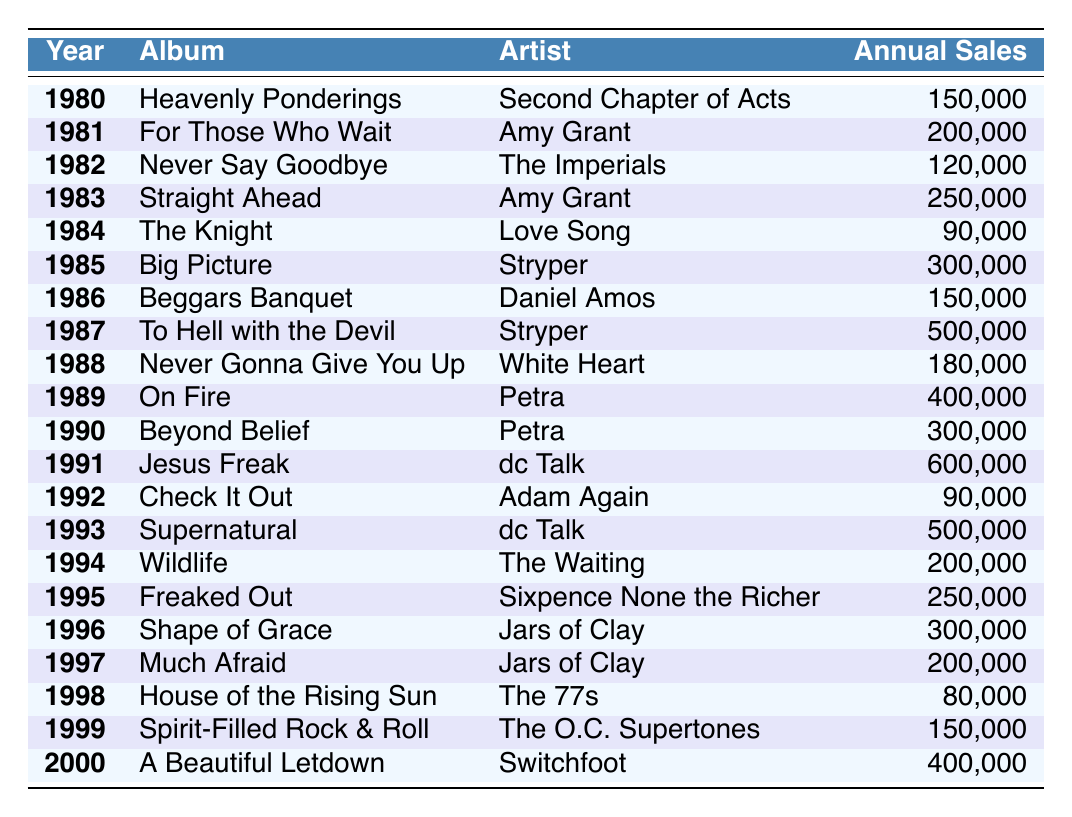What is the total annual sales of albums in 1991? The table shows that the annual sales for the album "Jesus Freak" by dc Talk is 600,000 in 1991. There are no other albums listed for that year.
Answer: 600,000 Which album had the highest annual sales in the table? The album "Jesus Freak" by dc Talk, released in 1991, had the highest annual sales at 600,000, greater than any other album listed in the table.
Answer: Jesus Freak How many albums had annual sales greater than 300,000? The albums with annual sales greater than 300,000 are "To Hell with the Devil" (500,000), "Jesus Freak" (600,000), "Supernatural" (500,000), and "On Fire" (400,000), totaling 4 albums.
Answer: 4 What is the difference in annual sales between the highest and lowest selling albums? The highest selling album is "Jesus Freak" with 600,000 sales, and the lowest is "House of the Rising Sun" with 80,000 sales. The difference is 600,000 - 80,000 = 520,000.
Answer: 520,000 Which artist had the most successful year based on sales in this table? The most successful year based on sales is 1991 with "Jesus Freak" by dc Talk, which sold 600,000 copies, more than any other artist's album in the table.
Answer: dc Talk What was the average annual sales of albums released in the 1980s? The annual sales for albums released in the 1980s are 150,000 (1980) + 200,000 (1981) + 120,000 (1982) + 250,000 (1983) + 90,000 (1984) + 300,000 (1985) + 150,000 (1986) + 500,000 (1987) + 180,000 (1988) + 400,000 (1989) = 2,180,000. Since there are 10 albums, the average is 2,180,000 / 10 = 218,000.
Answer: 218,000 Was there any album released in 1998 that had higher sales than 150,000? The album released in 1998 is "House of the Rising Sun" with annual sales of 80,000, which is not greater than 150,000. Therefore, there are no albums from that year with higher sales.
Answer: No List the top three albums by annual sales from 1987 to 1990. The albums from 1987 to 1990 are "To Hell with the Devil" by Stryper (500,000), "On Fire" by Petra (400,000), and "Beyond Belief" by Petra (300,000). The top three by sales are 1) To Hell with the Devil, 2) On Fire, 3) Beyond Belief.
Answer: To Hell with the Devil, On Fire, Beyond Belief How many albums were released between 1982 and 1986? The albums released from 1982 to 1986 are "Never Say Goodbye" (1982), "Straight Ahead" (1983), "The Knight" (1984), "Big Picture" (1985), and "Beggars Banquet" (1986), totaling 5 albums.
Answer: 5 What is the total sales of all albums released in the 1990s? The total for the 1990s includes "Beyond Belief" (300,000 - 1990), "Jesus Freak" (600,000 - 1991), "Supernatural" (500,000 - 1993), "Wildlife" (200,000 - 1994), "Freaked Out" (250,000 - 1995), "Shape of Grace" (300,000 - 1996), "Much Afraid" (200,000 - 1997), "House of the Rising Sun" (80,000 - 1998), "Spirit-Filled Rock & Roll" (150,000 - 1999). Summing these gives 2,280,000.
Answer: 2,280,000 